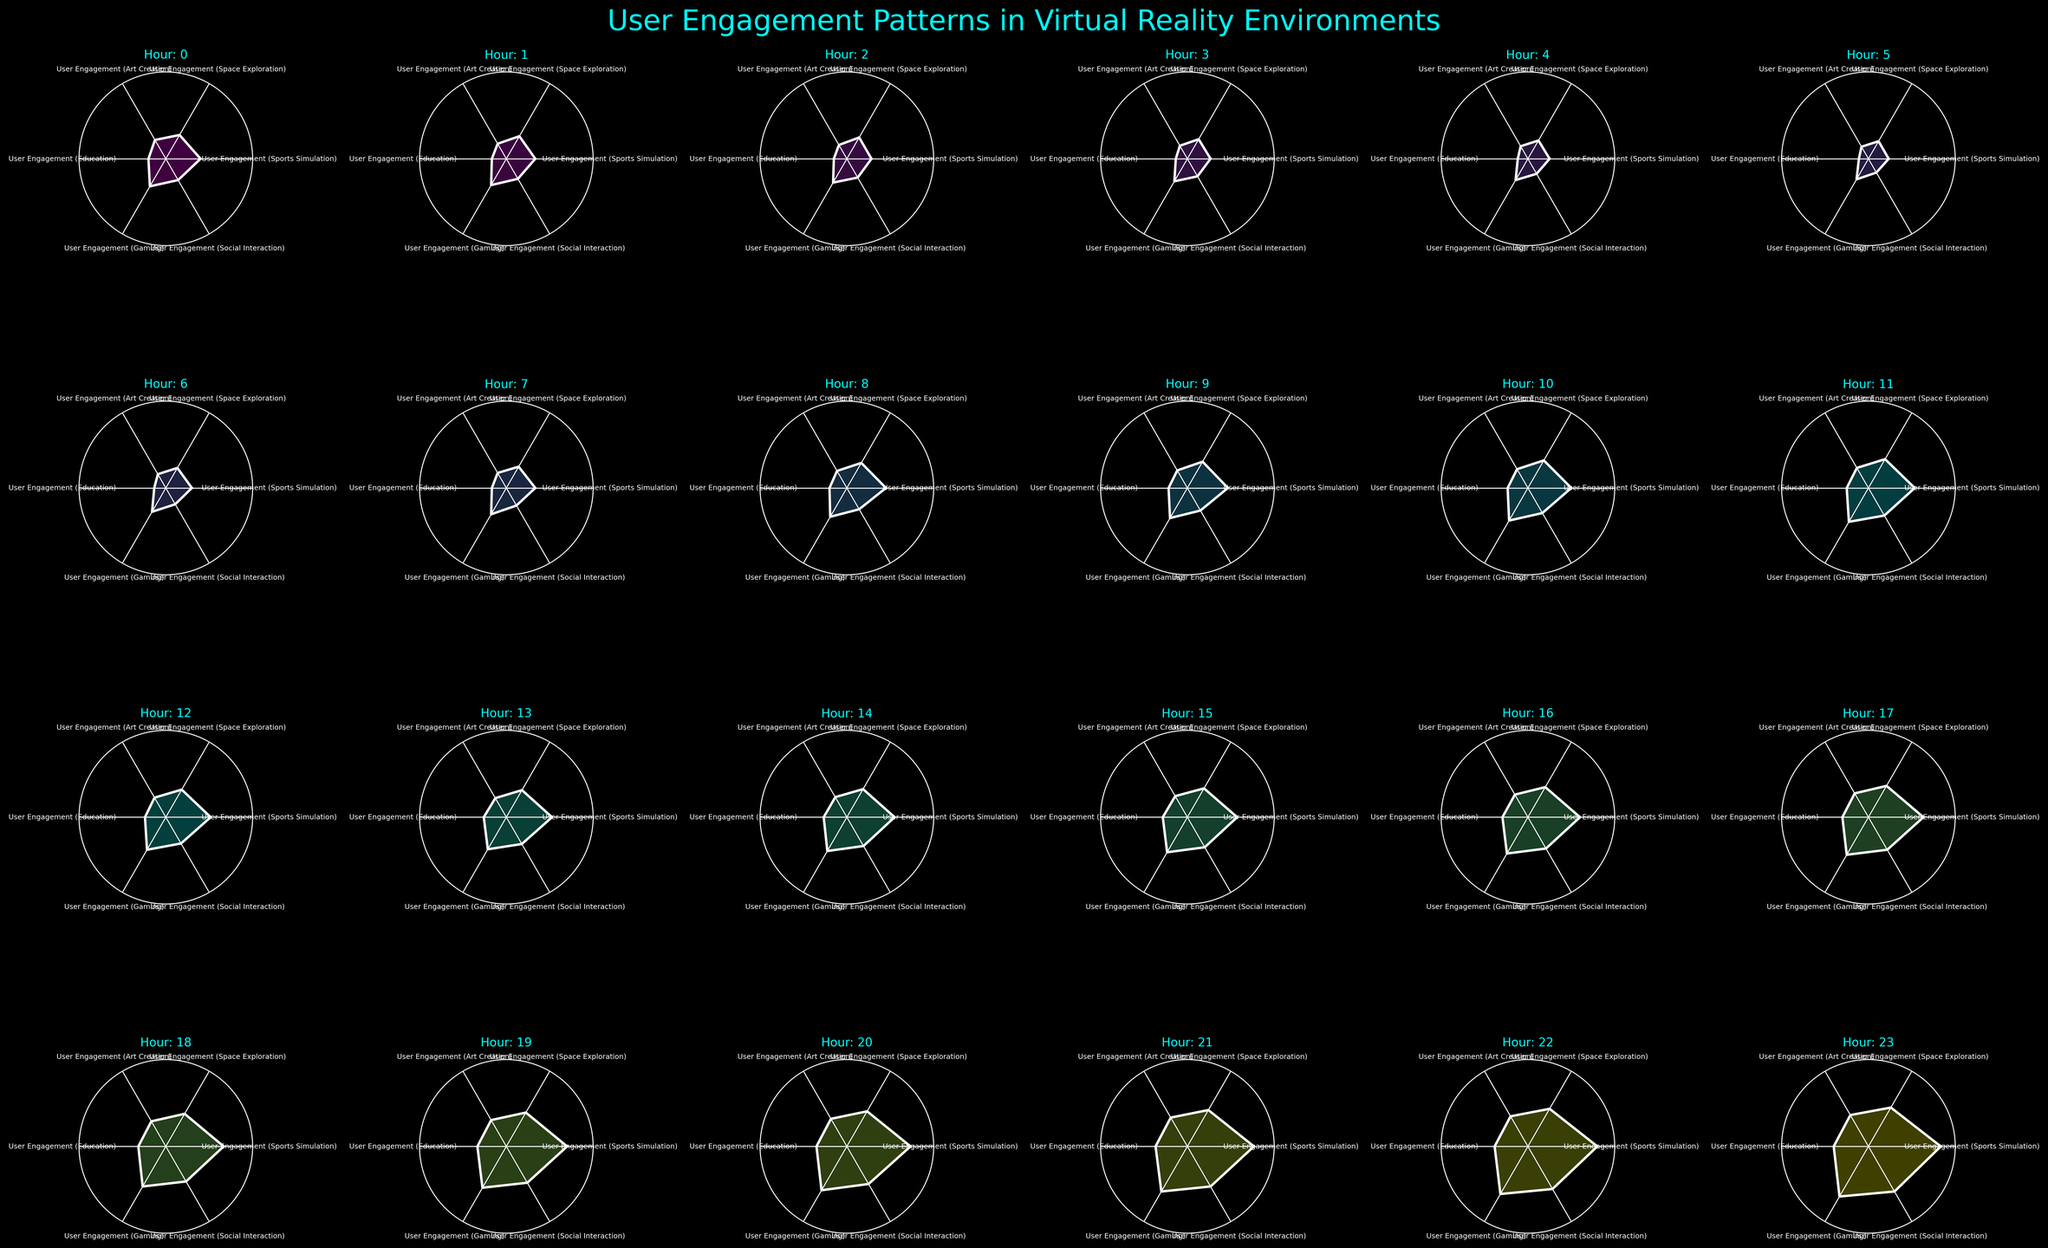How many subplots are present in the figure? Count the number of smaller plots within the entire figure. There are 4 rows and 6 columns, giving a total of 24 subplots.
Answer: 24 Which virtual reality environment has the highest user engagement at hour 18? Look for hour 18, then identify and compare the peaks in its corresponding subplot. The Gaming environment has the highest peak at 160.
Answer: Gaming During which hour is user engagement the lowest in all categories combined? Compare the engagement for all categories across all hours and identify the hour with the smallest cumulative height. This occurs at hour 5.
Answer: 5 What is the maximum user engagement recorded for Art Creation, and at what hour does it occur? Check the peak value in the rose chart for Art Creation across all hours. The maximum engagement is 125 at hour 23.
Answer: 125 at hour 23 Compare user engagement between Sports Simulation and Education at hour 10. Which is higher? Look at the heights of the respective segments for Sports Simulation and Education in the subplot for hour 10. Sports Simulation is higher with 150 compared to Education's 70.
Answer: Sports Simulation On average, which virtual reality environment has the highest user engagement? Compute the average user engagement for each environment across all hours. Sum values of each environment and divide by 24. The Gaming environment has the highest average.
Answer: Gaming Which environment shows consistent increase in user engagement throughout the day? Examine each subplot for a progressive increase in engagement from hour 0 to hour 23. The Social Interaction environment shows a consistent increase.
Answer: Social Interaction What is the total user engagement for Space Exploration at hours 12, 15, and 18? Add the values of user engagement for Space Exploration at the mentioned hours: 110 at hour 12 + 115 at hour 15 + 130 at hour 18 = 355.
Answer: 355 In the subplot for hour 21, which virtual reality environments have engagement values above 150? Identify the segments higher than 150 in the hour 21 subplot. Gaming (180) and Social Interaction (160) have values above 150.
Answer: Gaming and Social Interaction During which hours does user engagement for Education exceed 100? Look at the Education values in each subplot and find the hours where values exceed 100. This occurs at hours 19, 20, 21, 22, and 23.
Answer: 19, 20, 21, 22, 23 